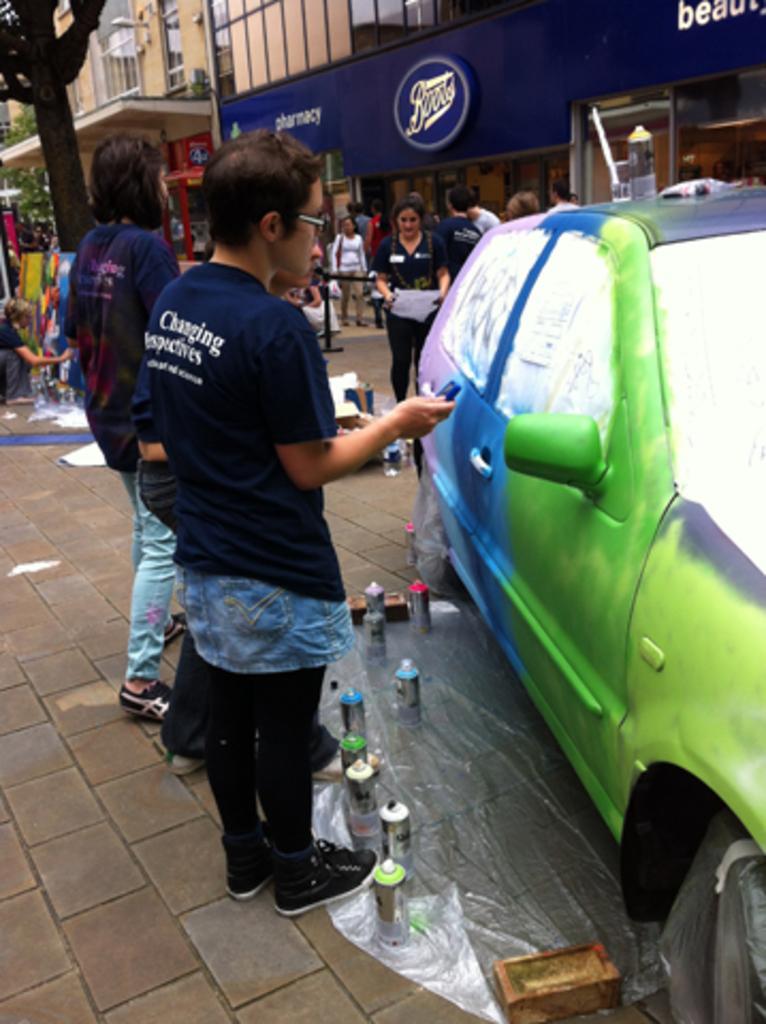Please provide a concise description of this image. In this image there is a car on a road and there are bottles and other items kept on a road, in the background there are people standing and there are buildings and there is a board on that board there is some text and there is are trees. 